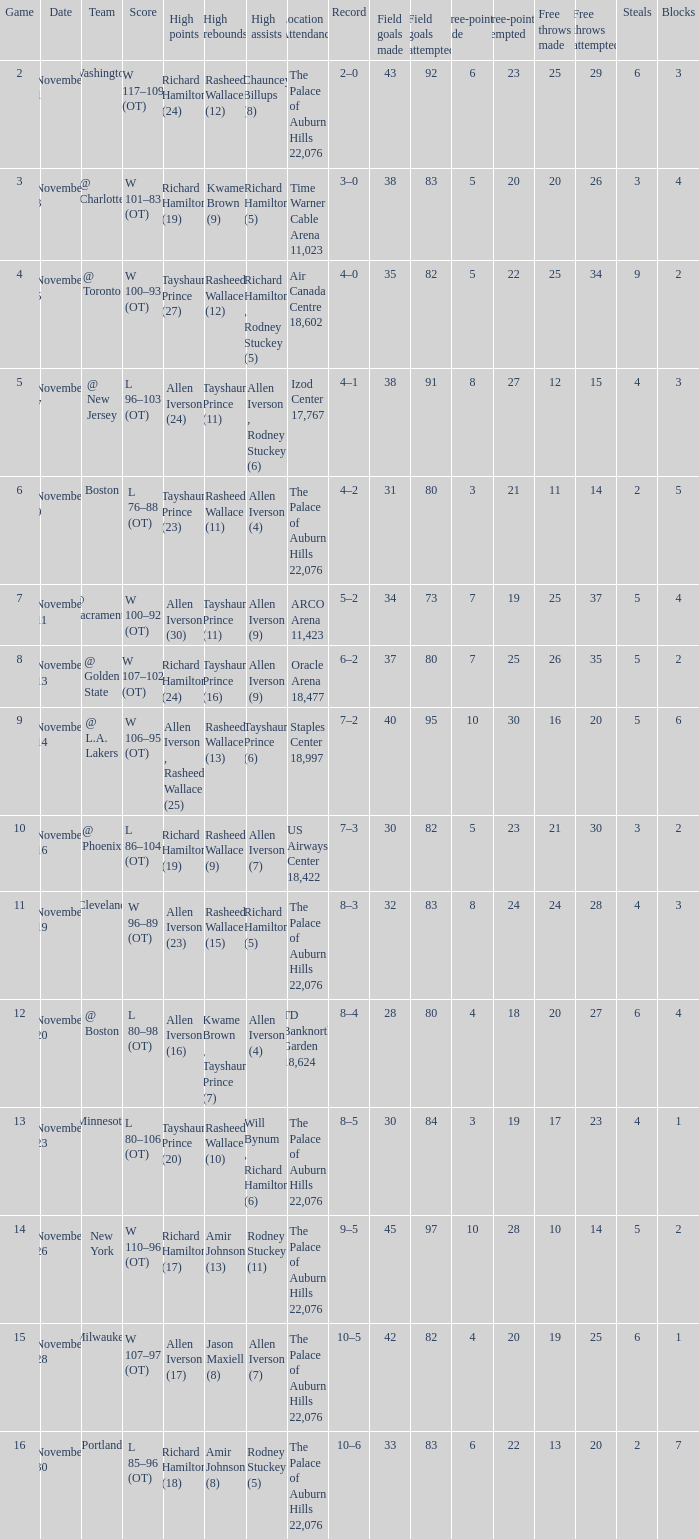What is High Points, when Game is "5"? Allen Iverson (24). 